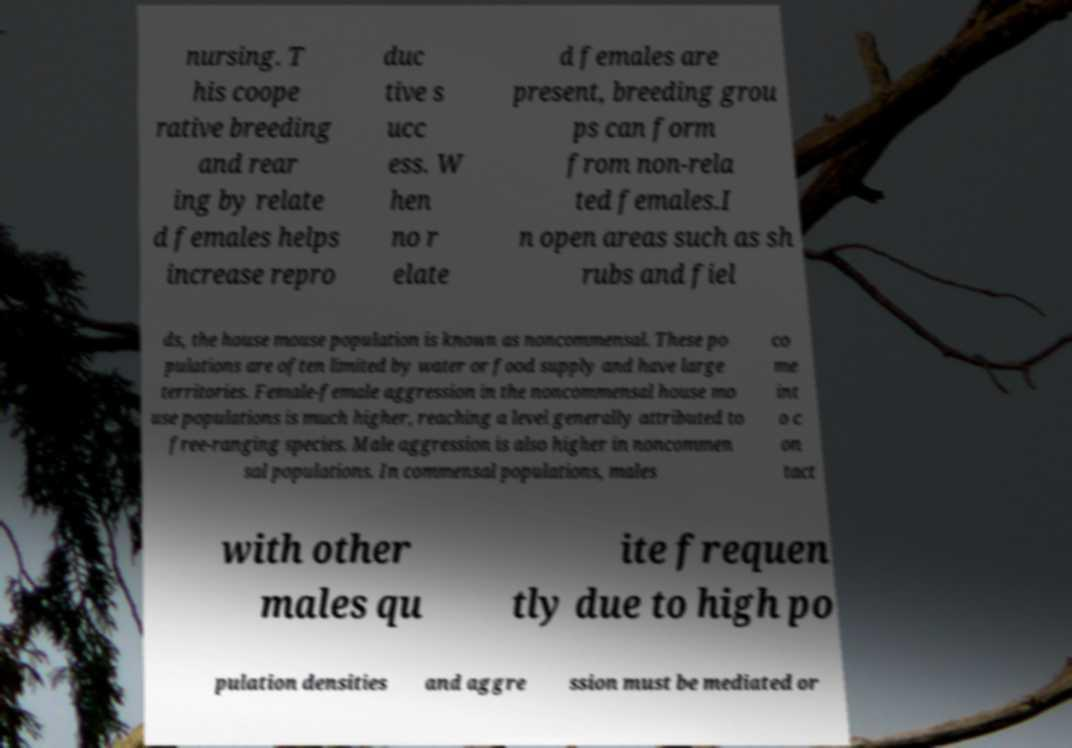Could you extract and type out the text from this image? nursing. T his coope rative breeding and rear ing by relate d females helps increase repro duc tive s ucc ess. W hen no r elate d females are present, breeding grou ps can form from non-rela ted females.I n open areas such as sh rubs and fiel ds, the house mouse population is known as noncommensal. These po pulations are often limited by water or food supply and have large territories. Female-female aggression in the noncommensal house mo use populations is much higher, reaching a level generally attributed to free-ranging species. Male aggression is also higher in noncommen sal populations. In commensal populations, males co me int o c on tact with other males qu ite frequen tly due to high po pulation densities and aggre ssion must be mediated or 